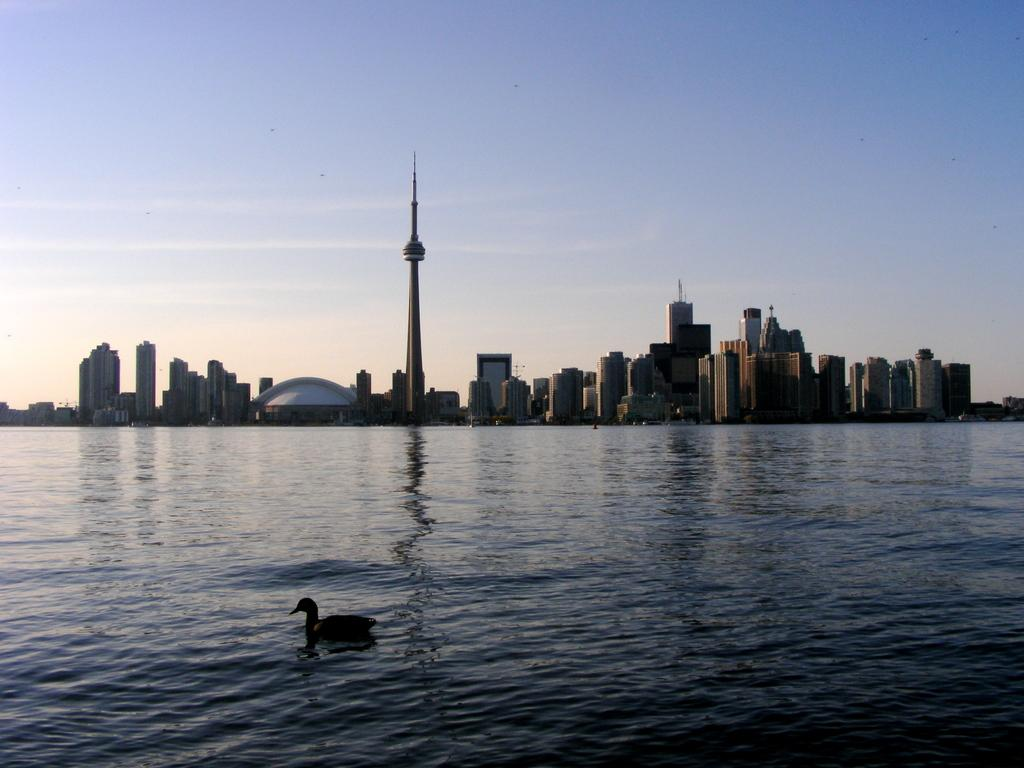What is the primary element visible in the image? There is a water surface in the image. What can be seen in the background of the image? There are buildings and towers behind the water surface. What type of animal is present in the water? A duck is swimming in the water. What type of art can be seen hanging in the image? There is no art present in the image. 